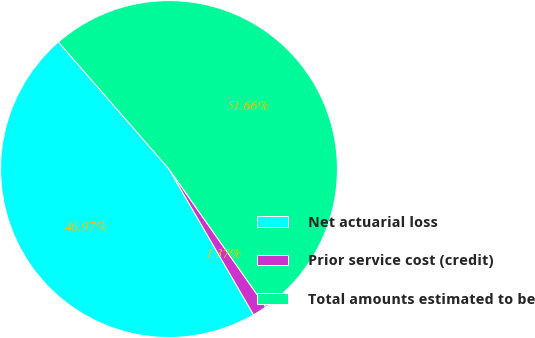Convert chart. <chart><loc_0><loc_0><loc_500><loc_500><pie_chart><fcel>Net actuarial loss<fcel>Prior service cost (credit)<fcel>Total amounts estimated to be<nl><fcel>46.97%<fcel>1.37%<fcel>51.66%<nl></chart> 